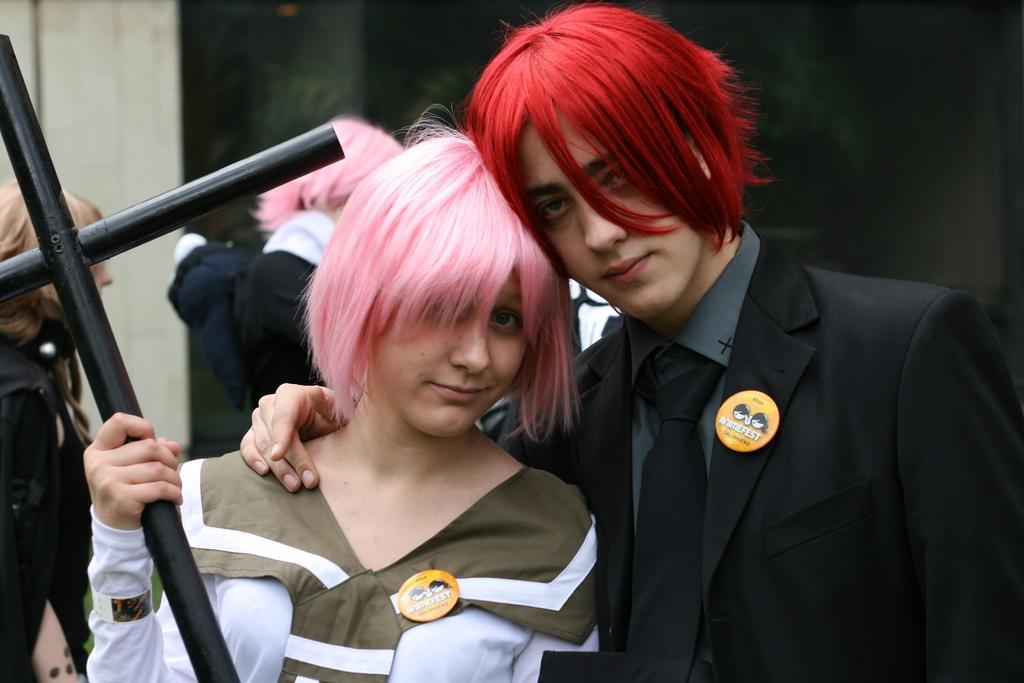Could you give a brief overview of what you see in this image? In this image I can see a group of people are standing on the floor and one person is holding a metal rod in hand. In the background I can see a wall. This image is taken may be during a day. 